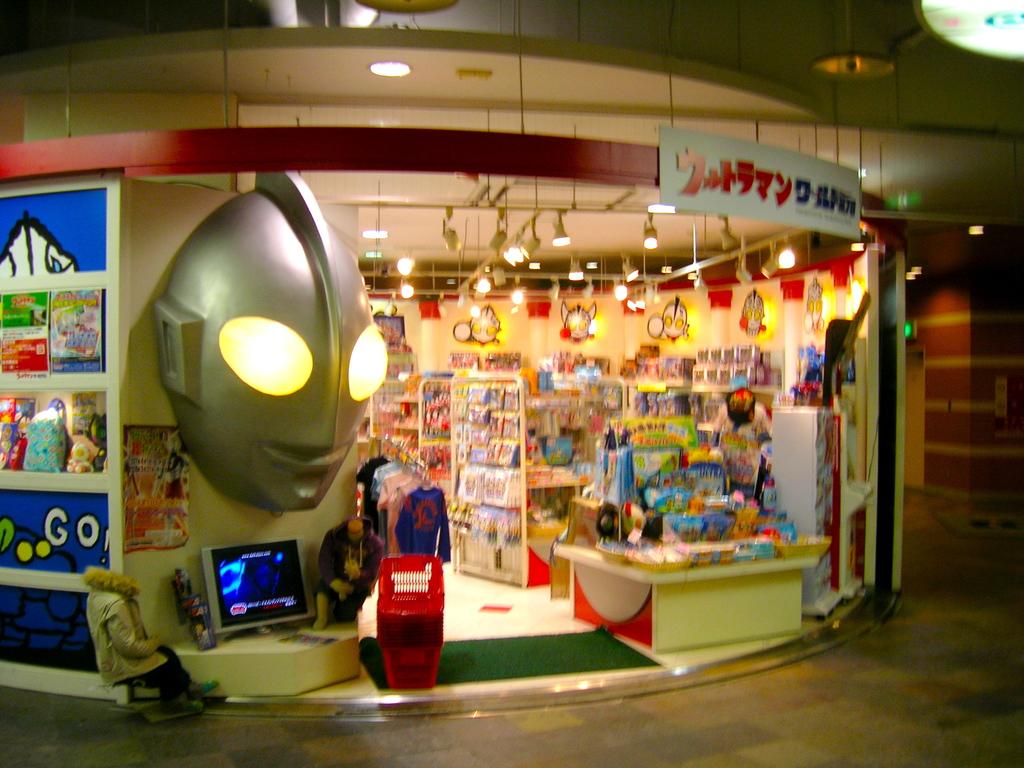What does it tell you to do on the left in blue?
Keep it short and to the point. Go. 